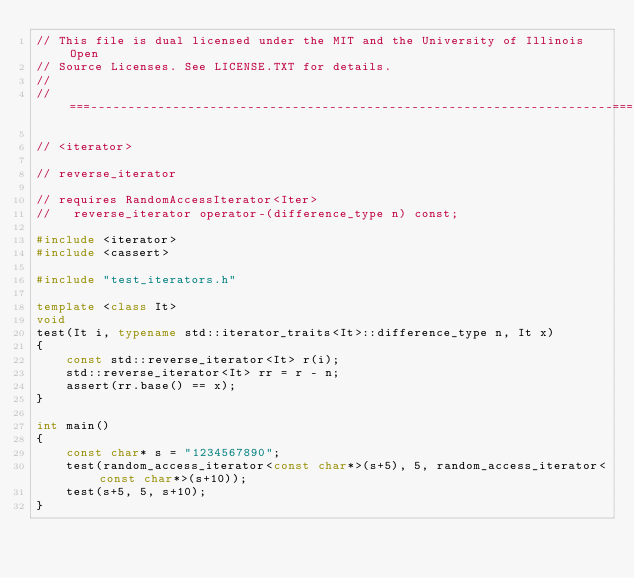Convert code to text. <code><loc_0><loc_0><loc_500><loc_500><_C++_>// This file is dual licensed under the MIT and the University of Illinois Open
// Source Licenses. See LICENSE.TXT for details.
//
//===----------------------------------------------------------------------===//

// <iterator>

// reverse_iterator

// requires RandomAccessIterator<Iter>
//   reverse_iterator operator-(difference_type n) const;

#include <iterator>
#include <cassert>

#include "test_iterators.h"

template <class It>
void
test(It i, typename std::iterator_traits<It>::difference_type n, It x)
{
    const std::reverse_iterator<It> r(i);
    std::reverse_iterator<It> rr = r - n;
    assert(rr.base() == x);
}

int main()
{
    const char* s = "1234567890";
    test(random_access_iterator<const char*>(s+5), 5, random_access_iterator<const char*>(s+10));
    test(s+5, 5, s+10);
}
</code> 